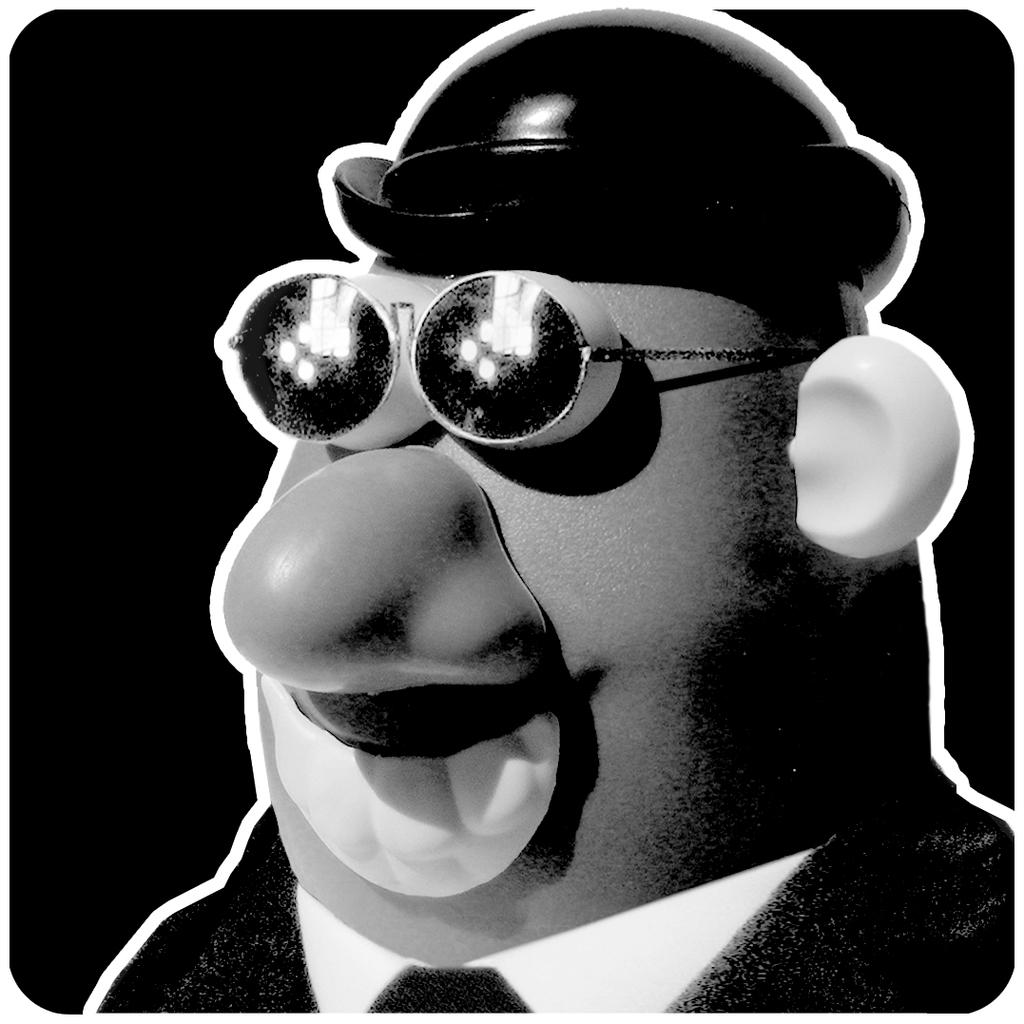What type of content is featured in the image? There is a cartoon in the image. What color is the background of the image? The background of the image is black. What day of the week is indicated on the calendar in the image? There is no calendar present in the image. What type of scent can be smelled coming from the grass in the image? There is no grass present in the image. 